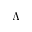<formula> <loc_0><loc_0><loc_500><loc_500>\Lambda</formula> 